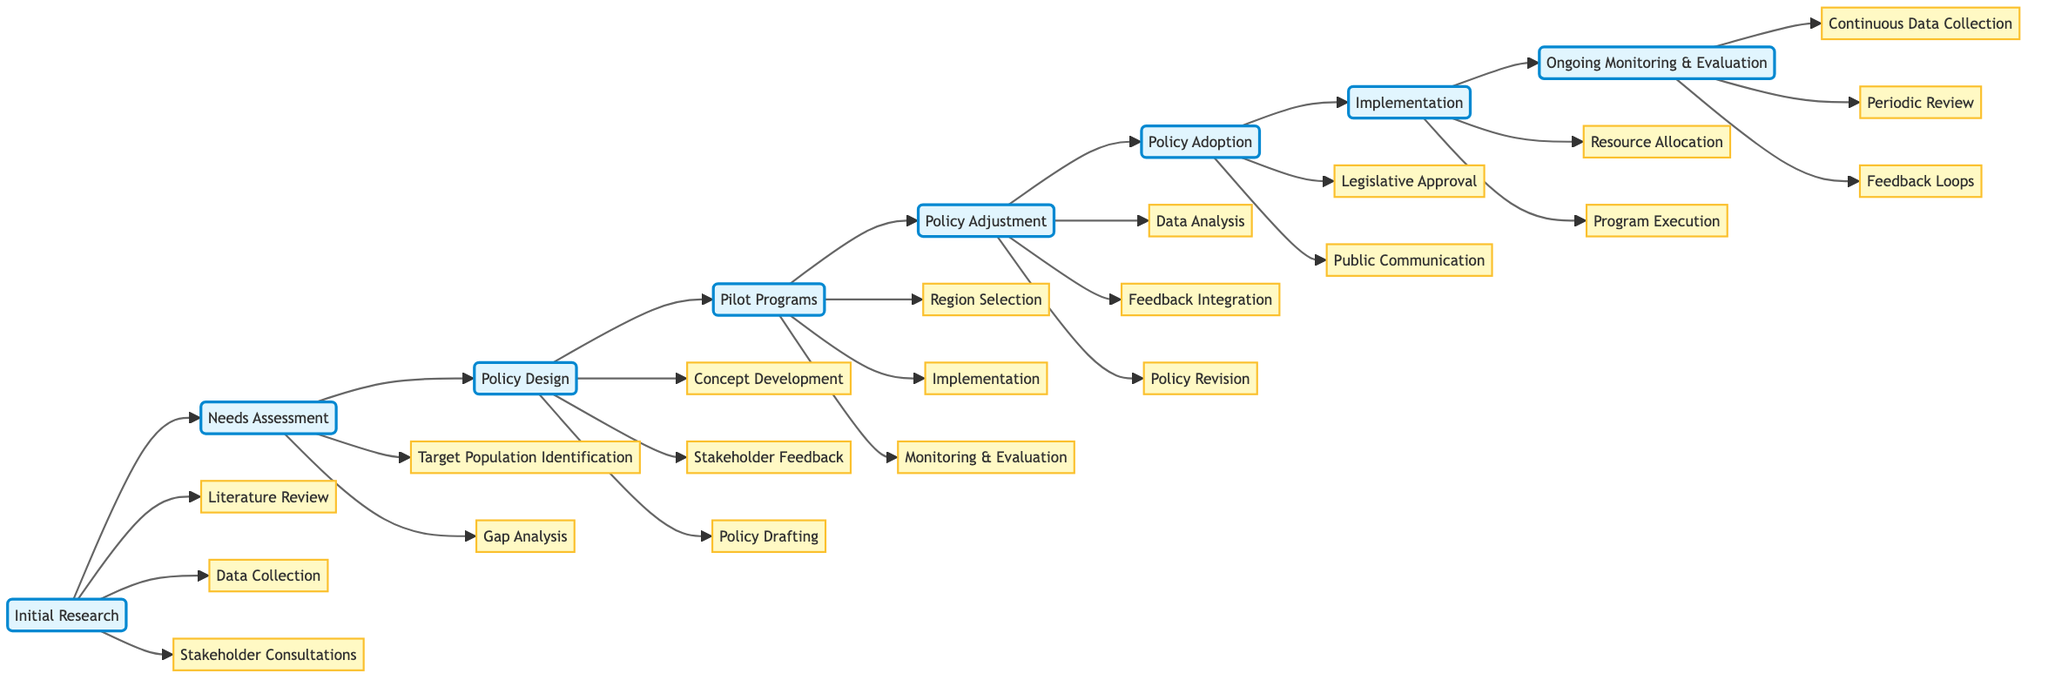What is the first step in the diagram? The first step in the flowchart is labeled "Initial Research," which is the starting point of the process for poverty reduction policy development.
Answer: Initial Research How many substeps are there in "Policy Design"? The "Policy Design" step has three substeps: "Concept Development," "Stakeholder Feedback," and "Policy Drafting." Counting these substeps results in a total of three.
Answer: 3 What follows "Pilot Programs" in the sequence? Looking at the flowchart, the step that immediately follows "Pilot Programs" is "Policy Adjustment." This indicates the next phase in policy development after conducting pilot programs.
Answer: Policy Adjustment What is the last step in the process? The last step in the horizontal flowchart, indicating the final phase of the policy development process, is "Ongoing Monitoring & Evaluation." This step involves the continuous assessment of the implemented policies.
Answer: Ongoing Monitoring & Evaluation Which step includes "Legislative Approval"? "Legislative Approval" is a substep found under the "Policy Adoption" step in the flowchart. This indicates that it is part of the process for adopting the policy.
Answer: Policy Adoption How many total steps are in the flowchart? By counting the main steps in the diagram, which are "Initial Research," "Needs Assessment," "Policy Design," "Pilot Programs," "Policy Adjustment," "Policy Adoption," "Implementation," and "Ongoing Monitoring & Evaluation," we find there are eight total steps.
Answer: 8 What are the first two activities in "Initial Research"? The first two activities listed under the "Initial Research" step are "Literature Review" and "Data Collection." These activities focus on gathering foundational information.
Answer: Literature Review, Data Collection Which step comes before "Implementation"? The step that comes just before "Implementation" in the flowchart is "Policy Adoption," meaning that policies must be adopted before they can be implemented on a wider scale.
Answer: Policy Adoption 